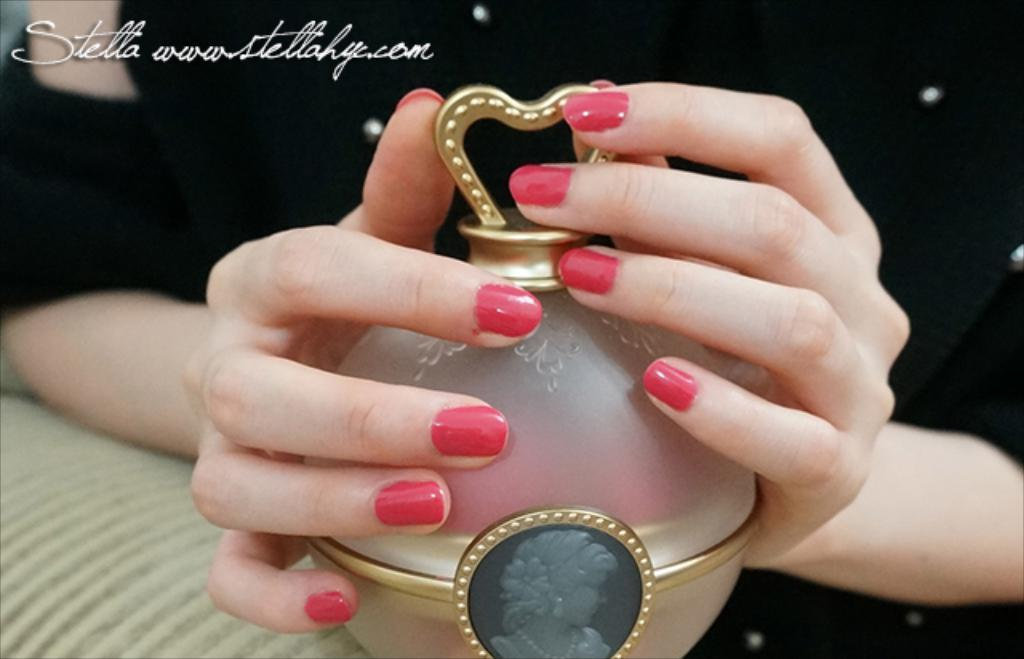<image>
Relay a brief, clear account of the picture shown. A ladies hands around a glass and metal dish with the web address for Stella HYC. 